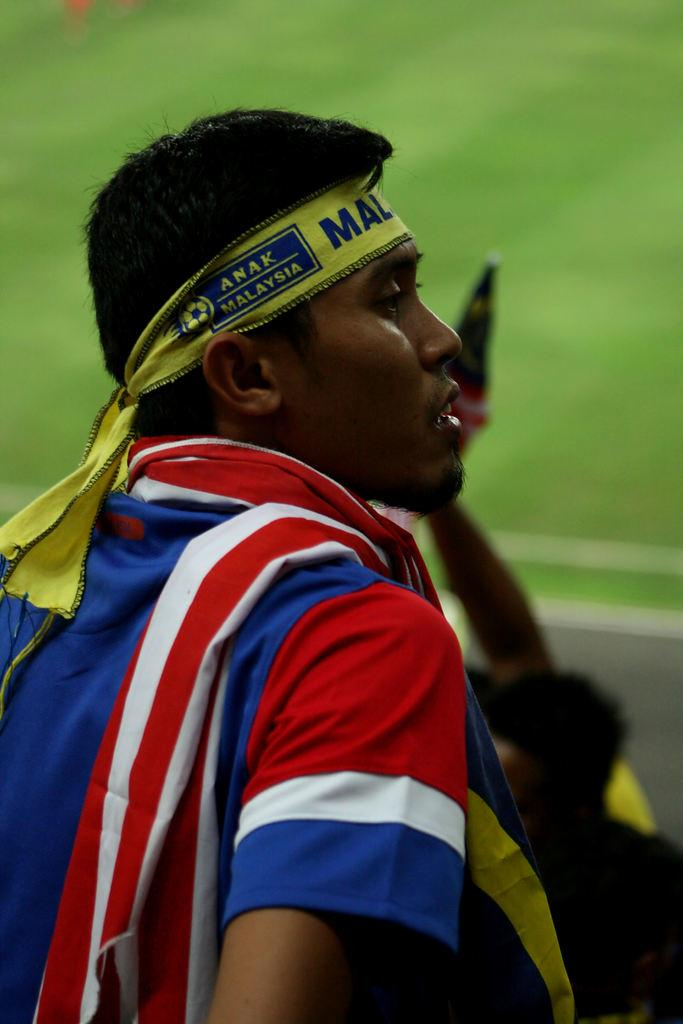Provide a one-sentence caption for the provided image. A Malaysia fan watches the game from the stands. 